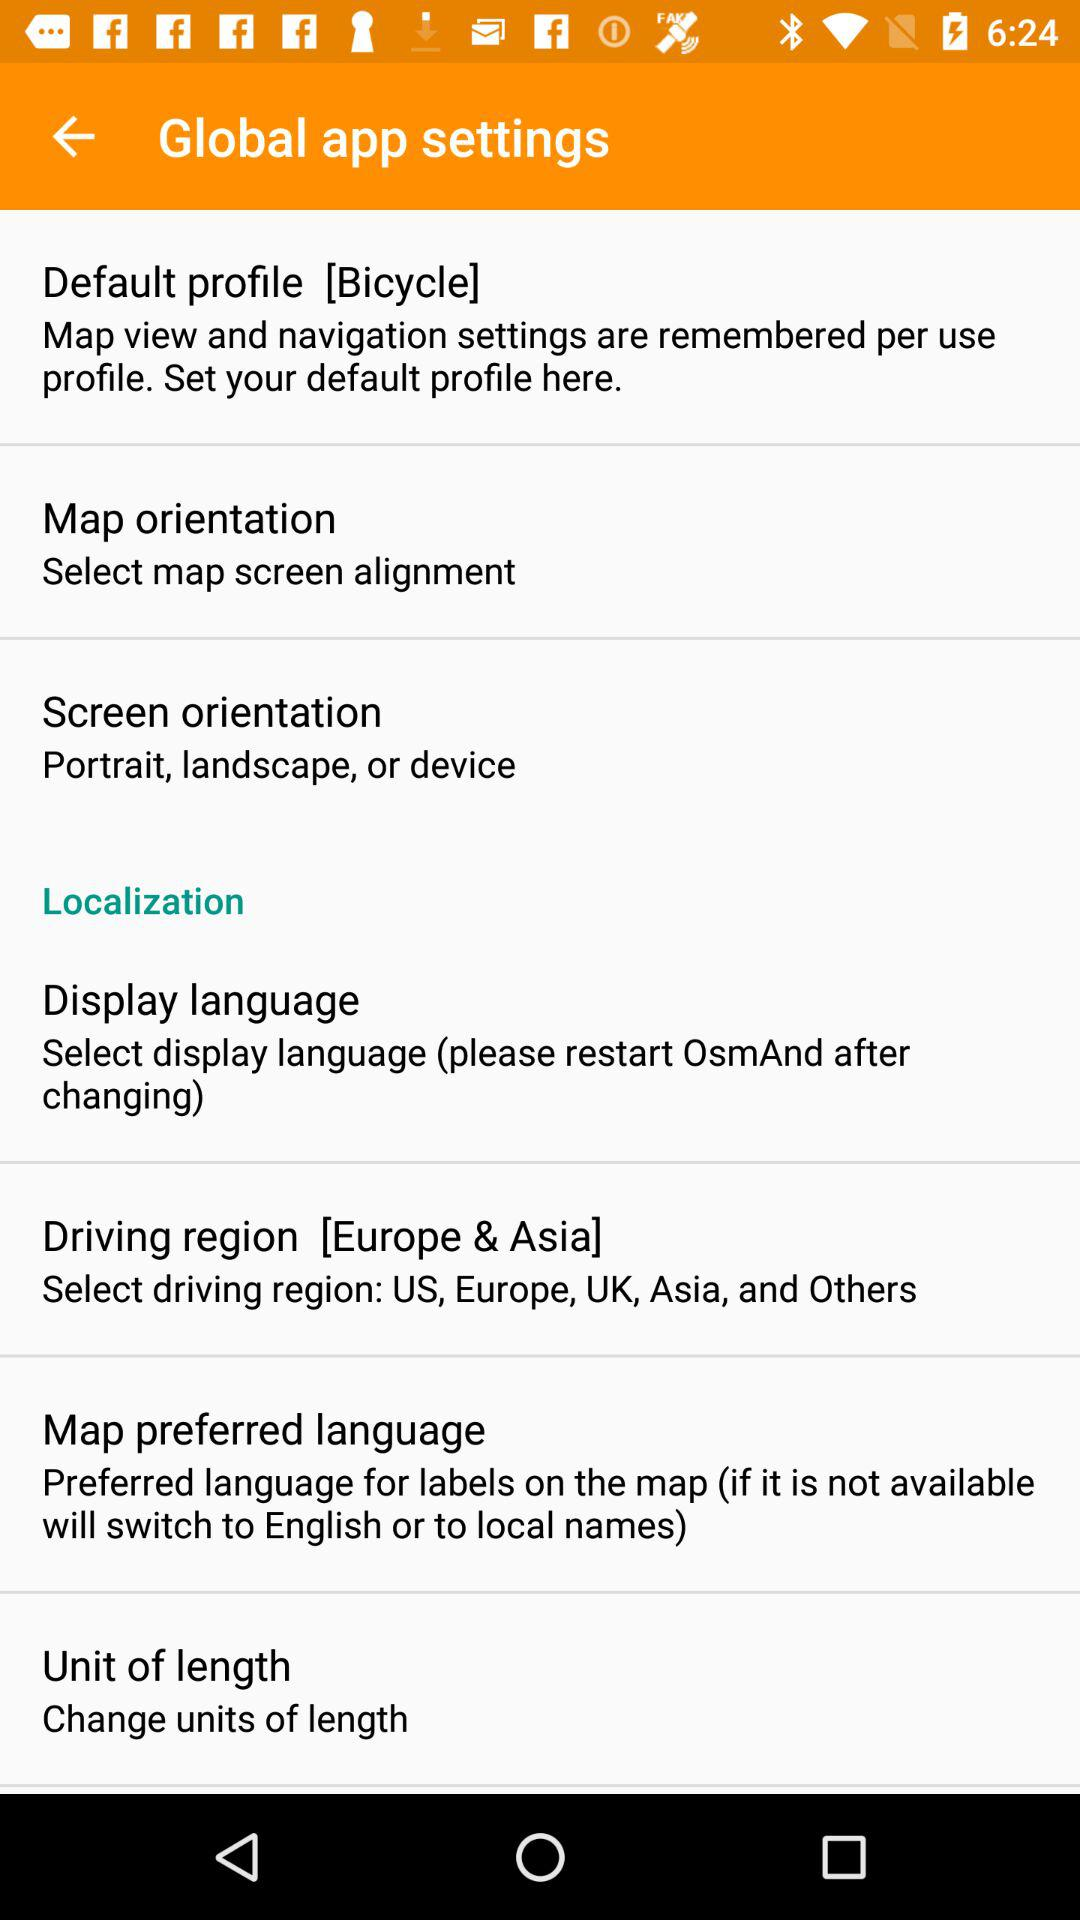What are the selected driving regions? The selected driving regions are Europe and Asia. 